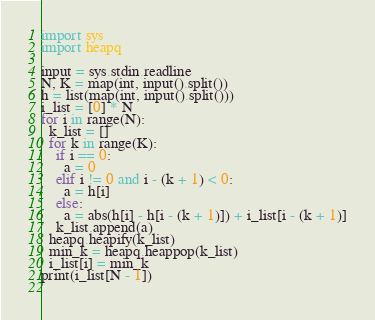<code> <loc_0><loc_0><loc_500><loc_500><_Python_>import sys
import heapq

input = sys.stdin.readline
N, K = map(int, input().split())
h = list(map(int, input().split()))
i_list = [0] * N
for i in range(N):
  k_list = []
  for k in range(K):
    if i == 0:
      a = 0
    elif i != 0 and i - (k + 1) < 0:
      a = h[i]
    else:
      a = abs(h[i] - h[i - (k + 1)]) + i_list[i - (k + 1)]
    k_list.append(a)
  heapq.heapify(k_list)
  min_k = heapq.heappop(k_list)
  i_list[i] = min_k
print(i_list[N - 1])
    </code> 